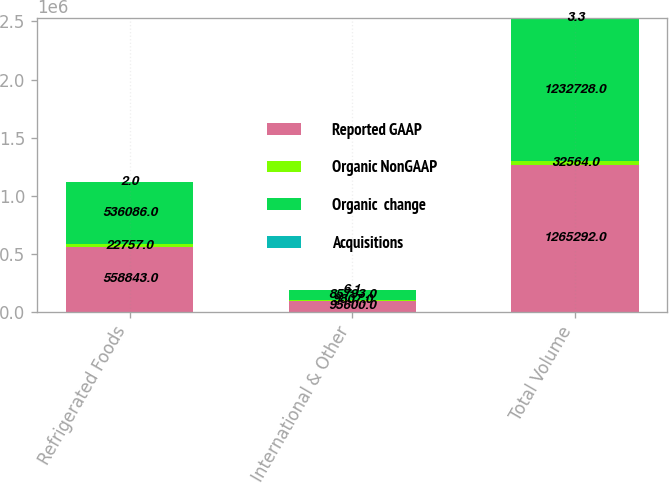Convert chart. <chart><loc_0><loc_0><loc_500><loc_500><stacked_bar_chart><ecel><fcel>Refrigerated Foods<fcel>International & Other<fcel>Total Volume<nl><fcel>Reported GAAP<fcel>558843<fcel>95600<fcel>1.26529e+06<nl><fcel>Organic NonGAAP<fcel>22757<fcel>9807<fcel>32564<nl><fcel>Organic  change<fcel>536086<fcel>85793<fcel>1.23273e+06<nl><fcel>Acquisitions<fcel>2<fcel>6.1<fcel>3.3<nl></chart> 